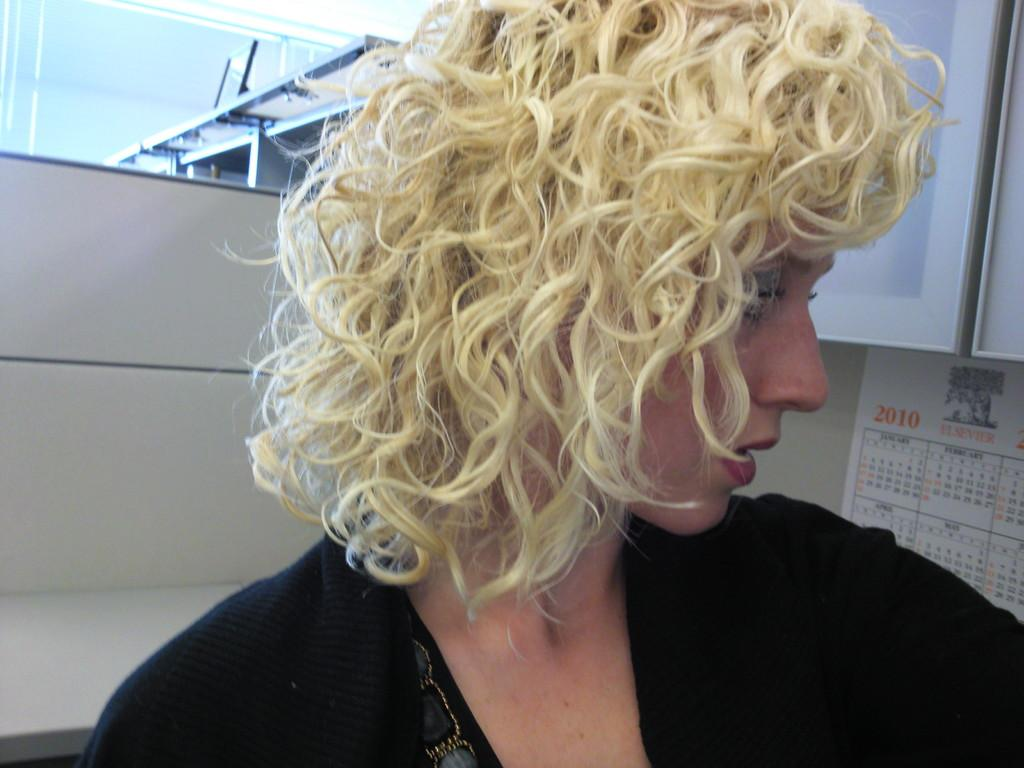Who is present in the image? There is a woman in the image. What is the woman wearing? The woman is wearing a black dress. What can be seen in the background of the image? There is a wall in the background of the image. What is on the wall in the background? There is a calendar on the wall in the background. What type of scarf is the woman wearing in the image? The woman is not wearing a scarf in the image. Can you see any scissors on the wall in the image? There are no scissors visible in the image. 